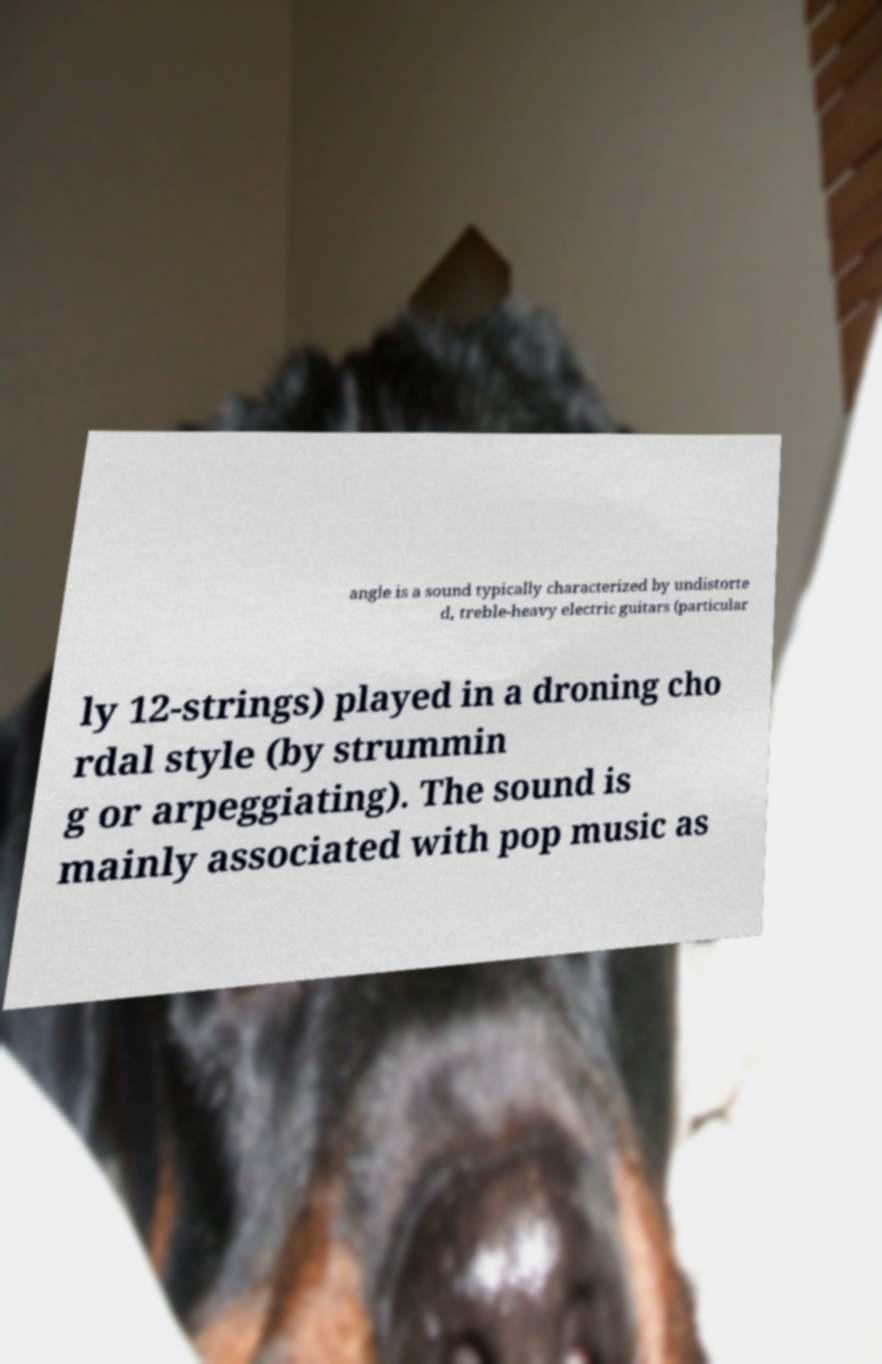I need the written content from this picture converted into text. Can you do that? angle is a sound typically characterized by undistorte d, treble-heavy electric guitars (particular ly 12-strings) played in a droning cho rdal style (by strummin g or arpeggiating). The sound is mainly associated with pop music as 